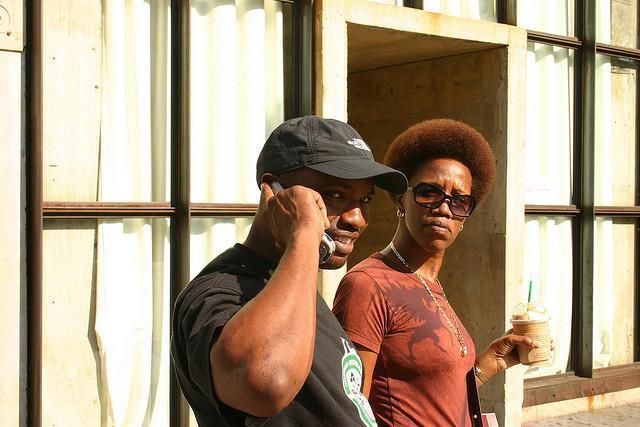How many people can you see?
Give a very brief answer. 2. How many birds are in the trees?
Give a very brief answer. 0. 